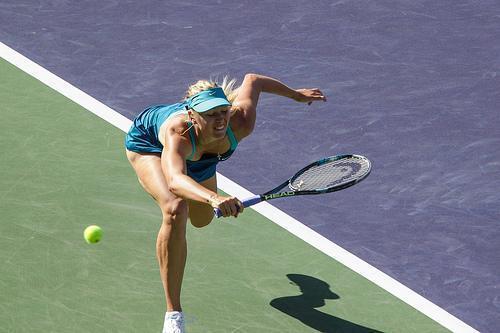How many balls?
Give a very brief answer. 1. 